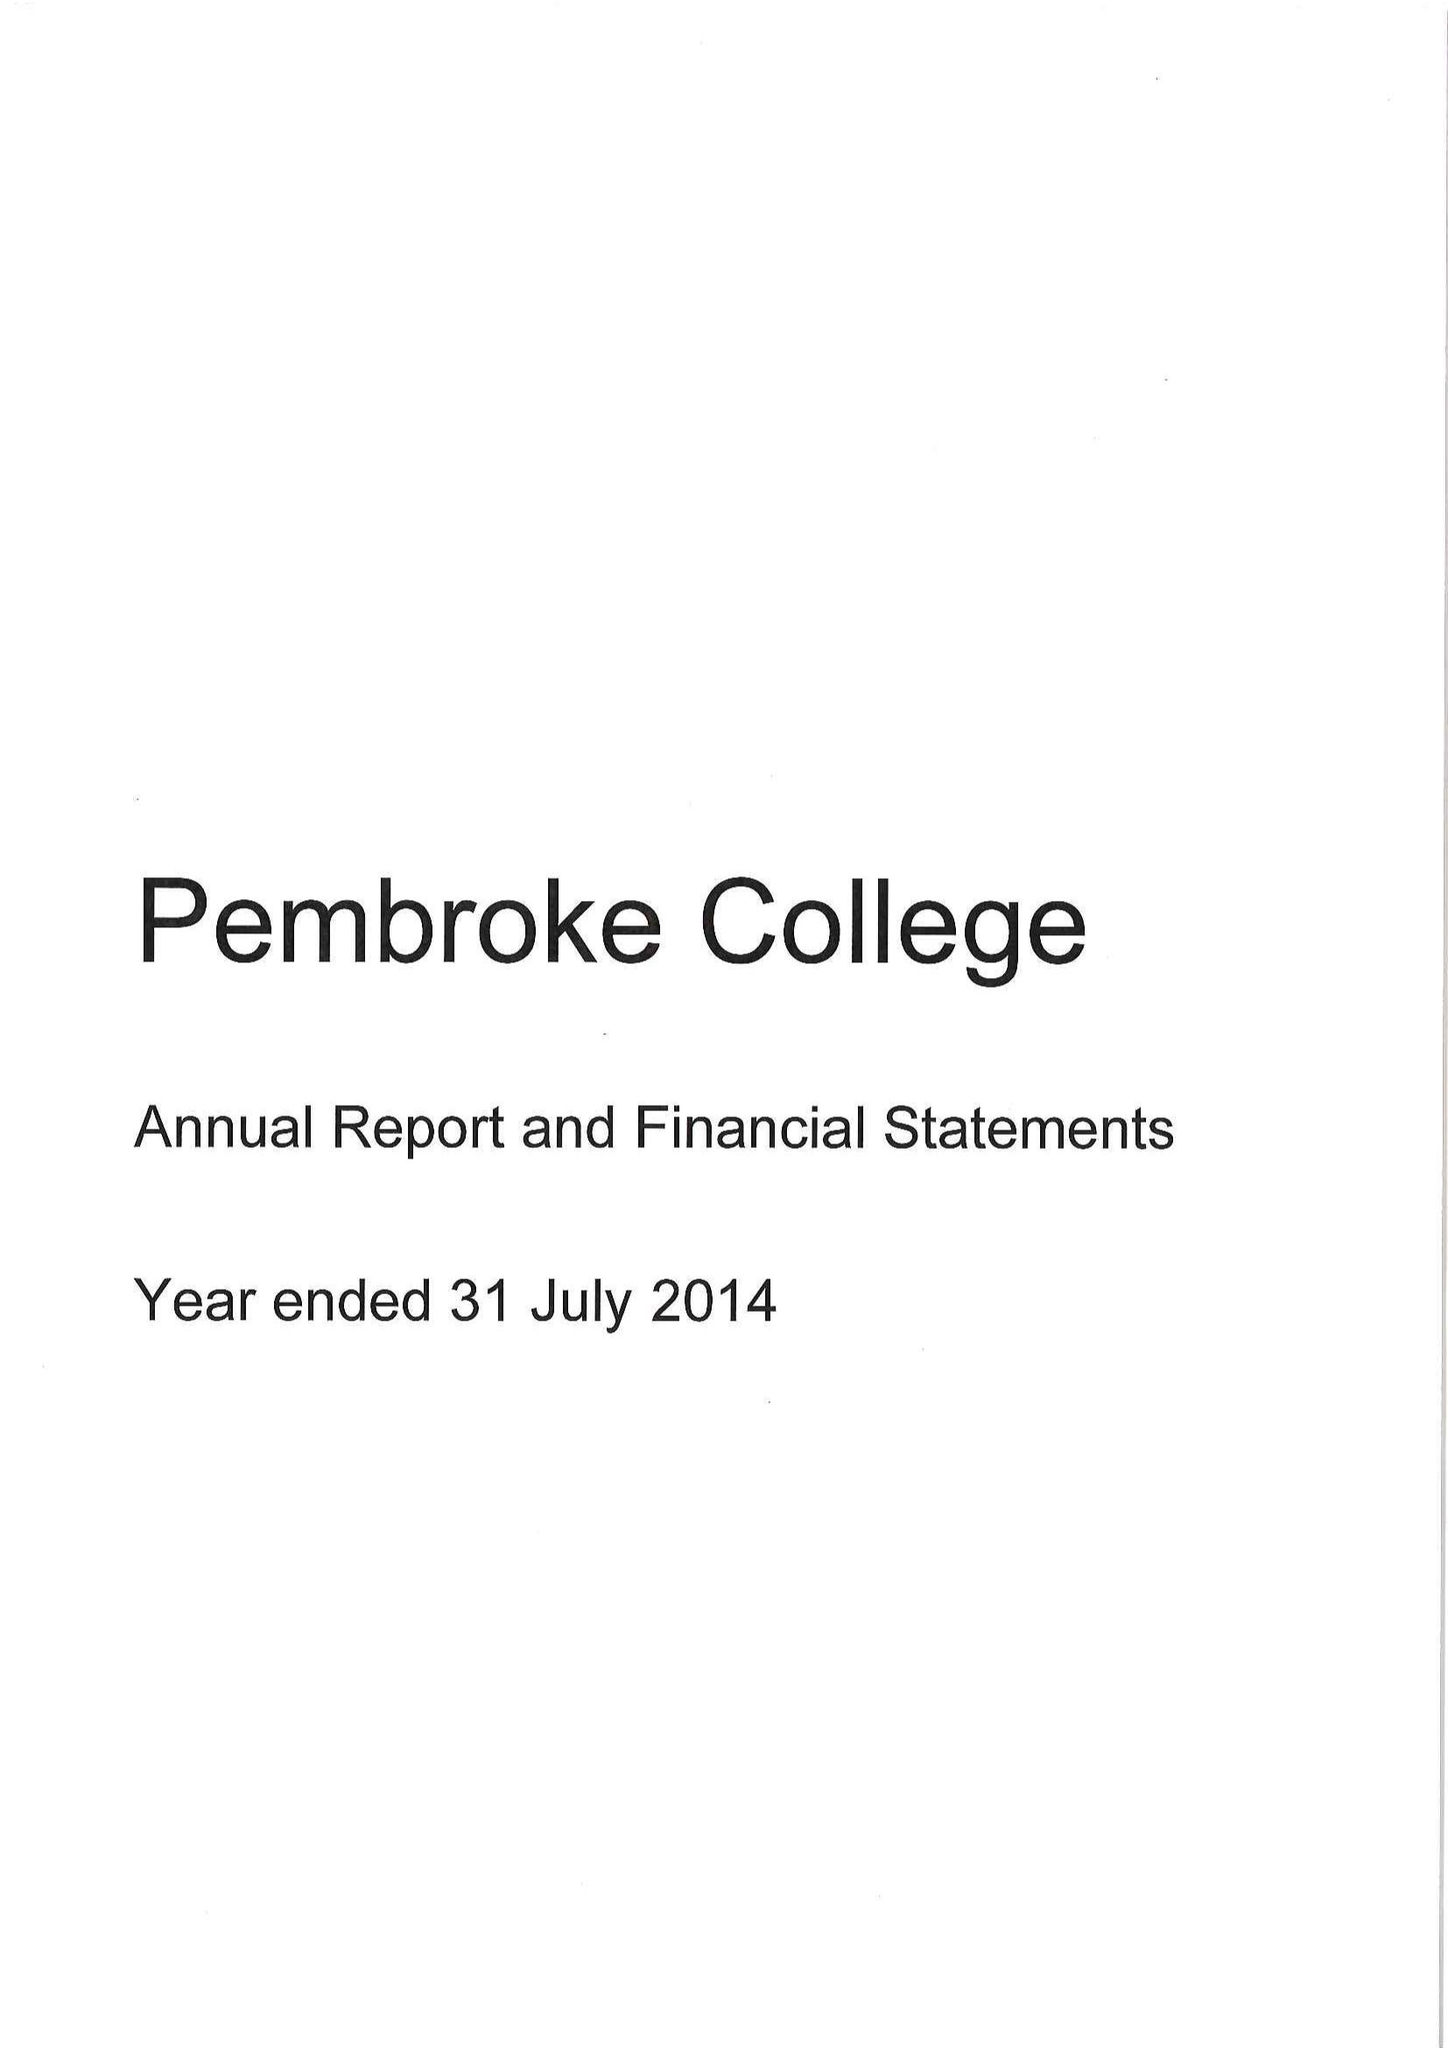What is the value for the charity_number?
Answer the question using a single word or phrase. 1137498 